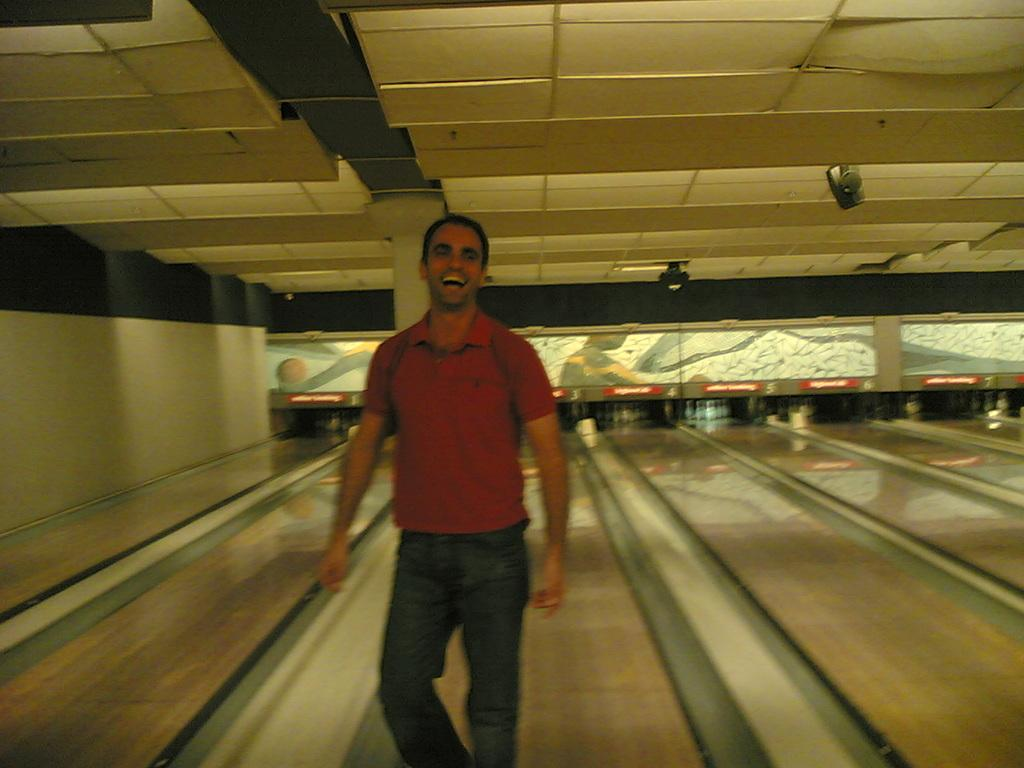Who is present in the image? There is a man in the image. What is the man wearing? The man is wearing a red t-shirt. What is the man doing in the image? The man is standing and smiling. What can be seen behind the man? There is a blowing behind the man. What architectural features are visible at the top of the image? There is a roof with pillars at the top of the image. What type of amusement can be seen in the aftermath of the sign in the image? There is no amusement or sign present in the image. 